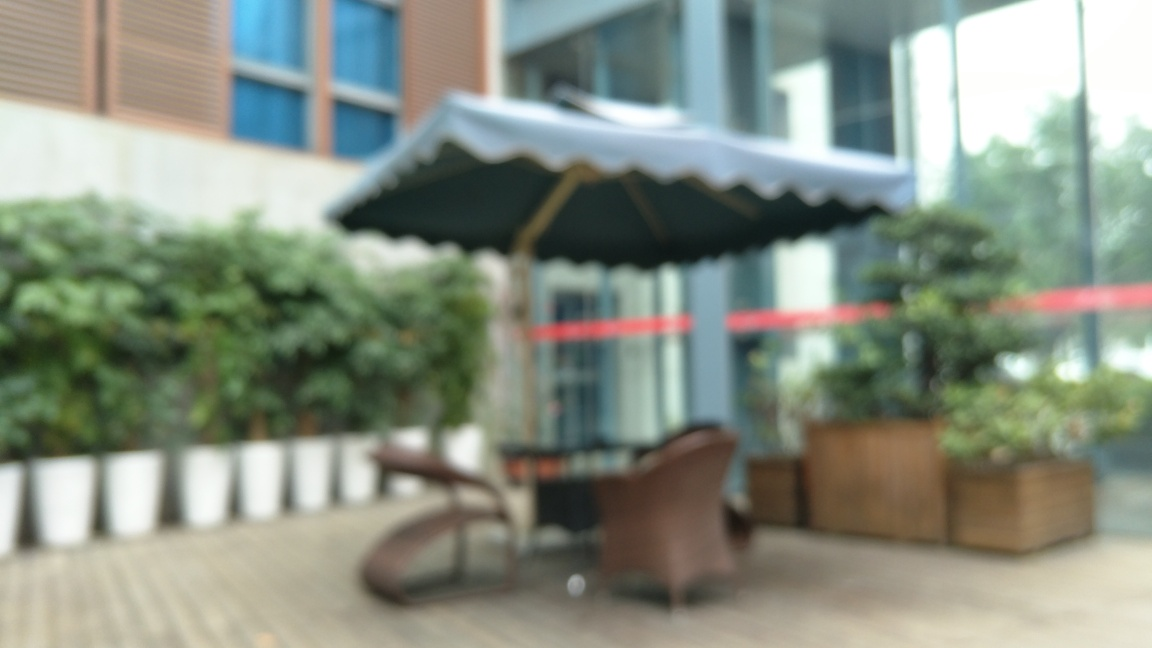Is this location suitable for relaxation? The presence of outdoor seating under an umbrella, combined with potted plants, suggests it is designed for relaxation. However, the blurred quality of the image prevents a detailed assessment of the atmosphere. 